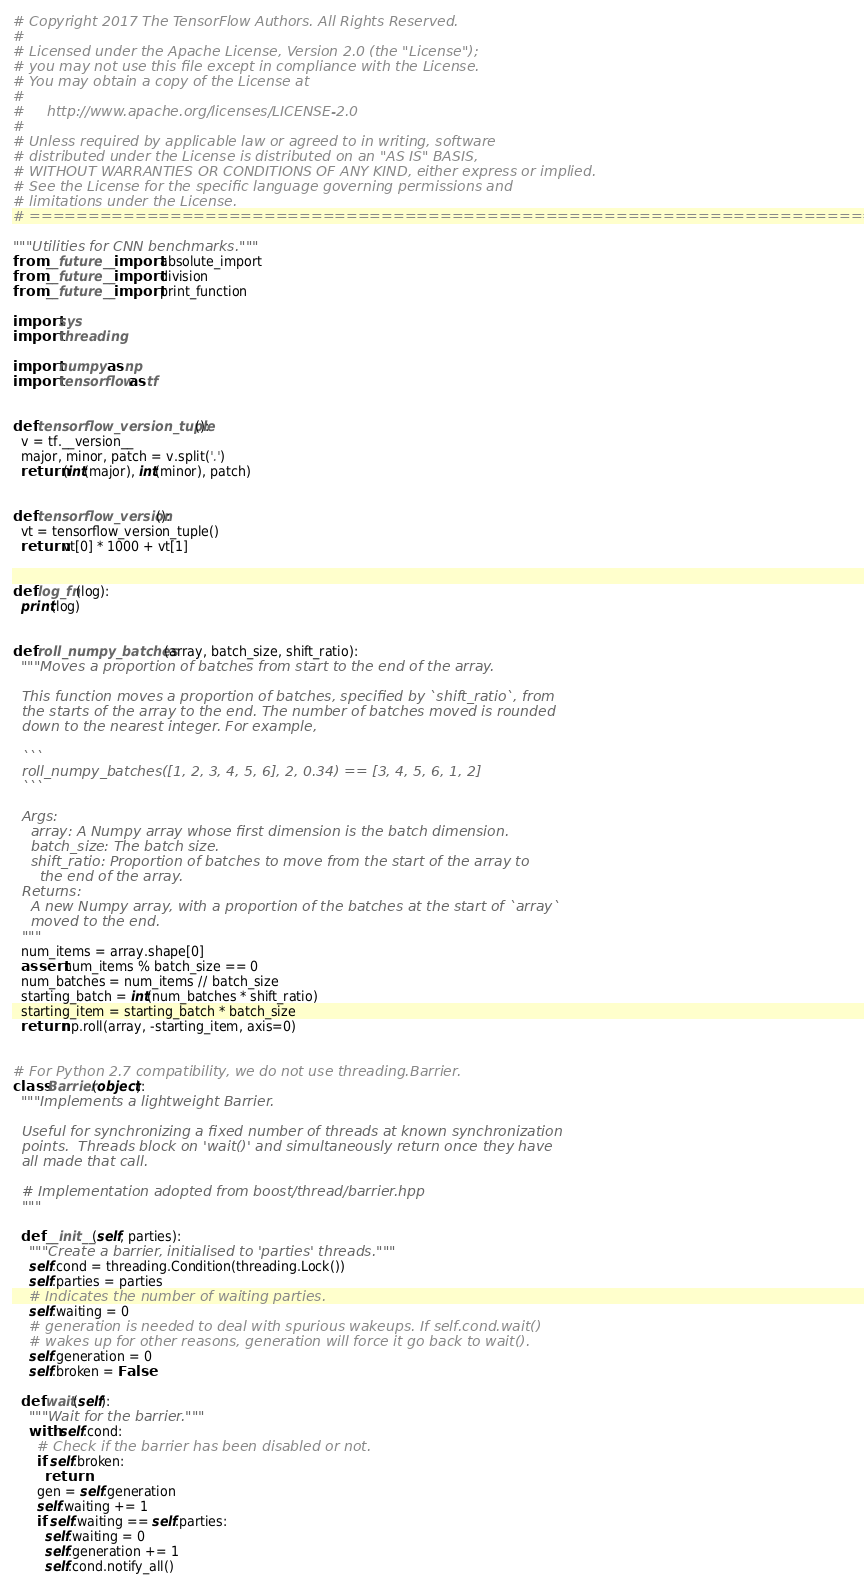<code> <loc_0><loc_0><loc_500><loc_500><_Python_># Copyright 2017 The TensorFlow Authors. All Rights Reserved.
#
# Licensed under the Apache License, Version 2.0 (the "License");
# you may not use this file except in compliance with the License.
# You may obtain a copy of the License at
#
#     http://www.apache.org/licenses/LICENSE-2.0
#
# Unless required by applicable law or agreed to in writing, software
# distributed under the License is distributed on an "AS IS" BASIS,
# WITHOUT WARRANTIES OR CONDITIONS OF ANY KIND, either express or implied.
# See the License for the specific language governing permissions and
# limitations under the License.
# ==============================================================================

"""Utilities for CNN benchmarks."""
from __future__ import absolute_import
from __future__ import division
from __future__ import print_function

import sys
import threading

import numpy as np
import tensorflow as tf


def tensorflow_version_tuple():
  v = tf.__version__
  major, minor, patch = v.split('.')
  return (int(major), int(minor), patch)


def tensorflow_version():
  vt = tensorflow_version_tuple()
  return vt[0] * 1000 + vt[1]


def log_fn(log):
  print(log)


def roll_numpy_batches(array, batch_size, shift_ratio):
  """Moves a proportion of batches from start to the end of the array.

  This function moves a proportion of batches, specified by `shift_ratio`, from
  the starts of the array to the end. The number of batches moved is rounded
  down to the nearest integer. For example,

  ```
  roll_numpy_batches([1, 2, 3, 4, 5, 6], 2, 0.34) == [3, 4, 5, 6, 1, 2]
  ```

  Args:
    array: A Numpy array whose first dimension is the batch dimension.
    batch_size: The batch size.
    shift_ratio: Proportion of batches to move from the start of the array to
      the end of the array.
  Returns:
    A new Numpy array, with a proportion of the batches at the start of `array`
    moved to the end.
  """
  num_items = array.shape[0]
  assert num_items % batch_size == 0
  num_batches = num_items // batch_size
  starting_batch = int(num_batches * shift_ratio)
  starting_item = starting_batch * batch_size
  return np.roll(array, -starting_item, axis=0)


# For Python 2.7 compatibility, we do not use threading.Barrier.
class Barrier(object):
  """Implements a lightweight Barrier.

  Useful for synchronizing a fixed number of threads at known synchronization
  points.  Threads block on 'wait()' and simultaneously return once they have
  all made that call.

  # Implementation adopted from boost/thread/barrier.hpp
  """

  def __init__(self, parties):
    """Create a barrier, initialised to 'parties' threads."""
    self.cond = threading.Condition(threading.Lock())
    self.parties = parties
    # Indicates the number of waiting parties.
    self.waiting = 0
    # generation is needed to deal with spurious wakeups. If self.cond.wait()
    # wakes up for other reasons, generation will force it go back to wait().
    self.generation = 0
    self.broken = False

  def wait(self):
    """Wait for the barrier."""
    with self.cond:
      # Check if the barrier has been disabled or not.
      if self.broken:
        return
      gen = self.generation
      self.waiting += 1
      if self.waiting == self.parties:
        self.waiting = 0
        self.generation += 1
        self.cond.notify_all()</code> 